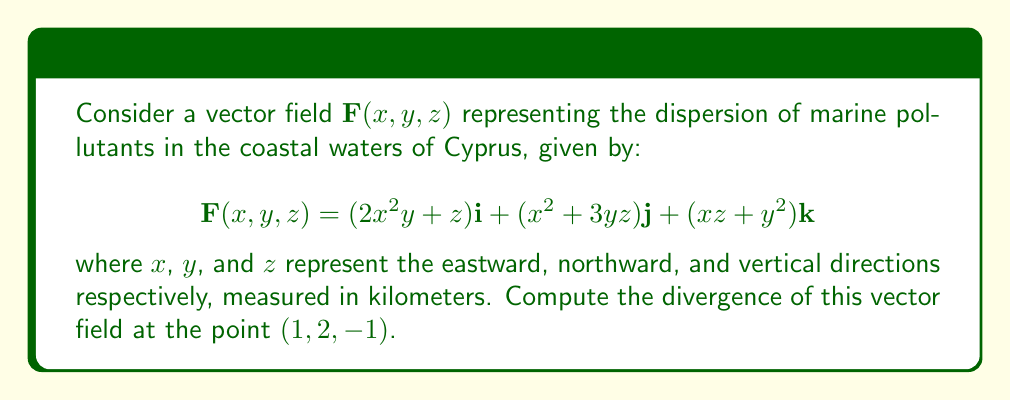Teach me how to tackle this problem. To compute the divergence of the vector field $\mathbf{F}(x, y, z)$, we need to follow these steps:

1) The divergence of a vector field in 3D is given by:

   $$\text{div}\mathbf{F} = \nabla \cdot \mathbf{F} = \frac{\partial F_x}{\partial x} + \frac{\partial F_y}{\partial y} + \frac{\partial F_z}{\partial z}$$

2) Let's identify each component of $\mathbf{F}$:
   
   $F_x = 2x^2y + z$
   $F_y = x^2 + 3yz$
   $F_z = xz + y^2$

3) Now, let's calculate each partial derivative:

   $\frac{\partial F_x}{\partial x} = 4xy$
   
   $\frac{\partial F_y}{\partial y} = 3z$
   
   $\frac{\partial F_z}{\partial z} = x$

4) The divergence is the sum of these partial derivatives:

   $$\text{div}\mathbf{F} = 4xy + 3z + x$$

5) To find the divergence at the point $(1, 2, -1)$, we substitute these values:

   $$\text{div}\mathbf{F}(1, 2, -1) = 4(1)(2) + 3(-1) + 1 = 8 - 3 + 1 = 6$$

Therefore, the divergence of the vector field at the point $(1, 2, -1)$ is 6 km^-1.
Answer: 6 km^-1 